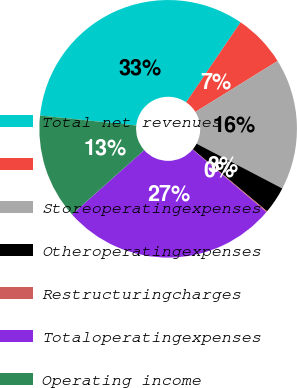Convert chart to OTSL. <chart><loc_0><loc_0><loc_500><loc_500><pie_chart><fcel>Total net revenues<fcel>Unnamed: 1<fcel>Storeoperatingexpenses<fcel>Otheroperatingexpenses<fcel>Restructuringcharges<fcel>Totaloperatingexpenses<fcel>Operating income<nl><fcel>32.85%<fcel>6.67%<fcel>16.49%<fcel>3.4%<fcel>0.13%<fcel>27.23%<fcel>13.22%<nl></chart> 